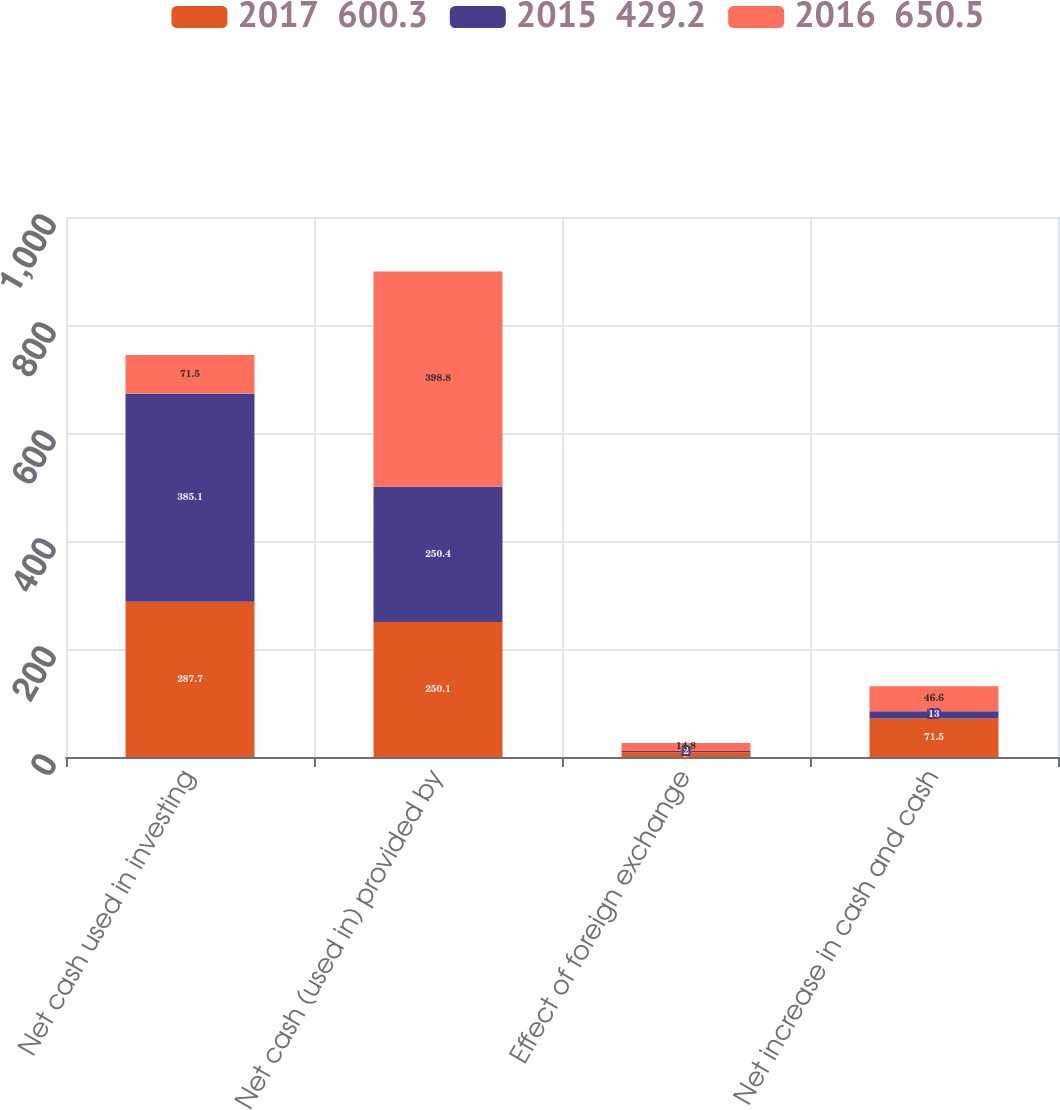<chart> <loc_0><loc_0><loc_500><loc_500><stacked_bar_chart><ecel><fcel>Net cash used in investing<fcel>Net cash (used in) provided by<fcel>Effect of foreign exchange<fcel>Net increase in cash and cash<nl><fcel>2017  600.3<fcel>287.7<fcel>250.1<fcel>9<fcel>71.5<nl><fcel>2015  429.2<fcel>385.1<fcel>250.4<fcel>2<fcel>13<nl><fcel>2016  650.5<fcel>71.5<fcel>398.8<fcel>14.8<fcel>46.6<nl></chart> 